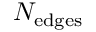Convert formula to latex. <formula><loc_0><loc_0><loc_500><loc_500>N _ { e d g e s }</formula> 